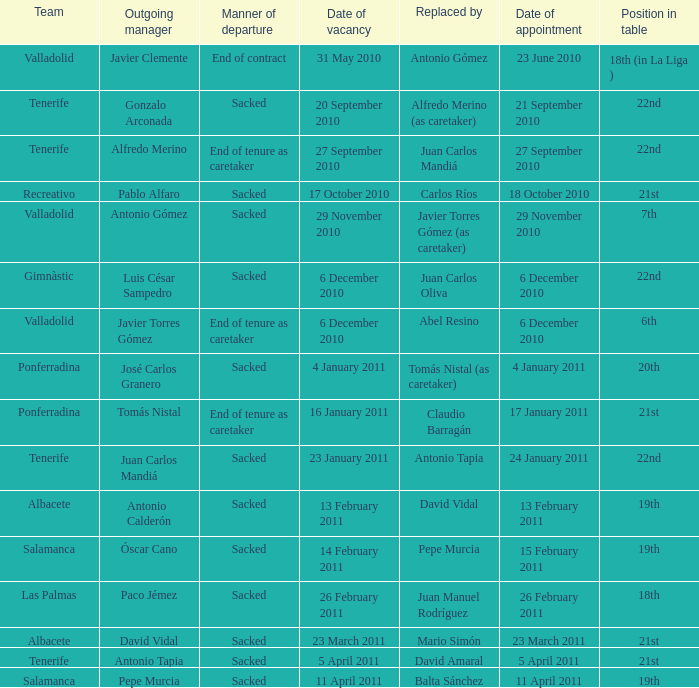What is the position for outgoing manager alfredo merino 22nd. 